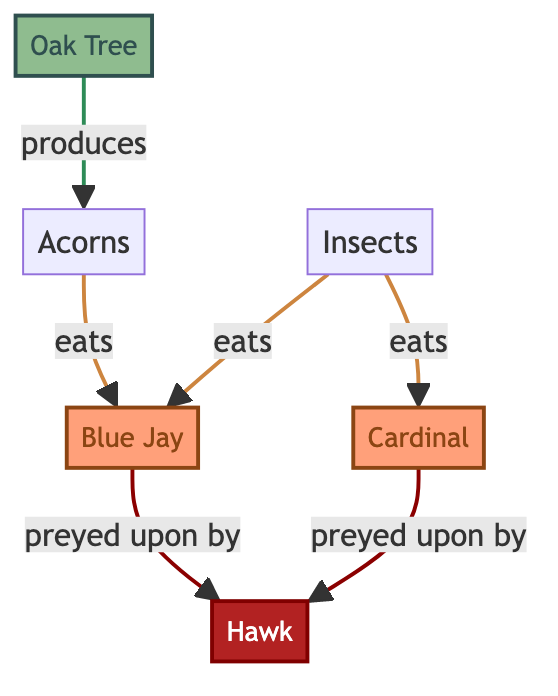What is the primary producer in this food chain? The diagram shows an Oak Tree as the starting point, which is indicated as the primary producer in this food chain.
Answer: Oak Tree How many consumer nodes are in the diagram? There are two consumer nodes, which are the Blue Jay and the Cardinal. By counting these nodes in the diagram, we find a total of two.
Answer: 2 What do Blue Jays eat in this food chain? The diagram indicates that Blue Jays eat both Acorns and Insects. This is clear from the arrows pointing towards the Blue Jay node from these two food sources.
Answer: Acorns and Insects Which bird is at the top of the food chain? The diagram specifies that the Hawk is the predator. It preys on the Blue Jay and Cardinal, placing it at the top of this food chain.
Answer: Hawk What food source do Cardials depend on for nutrition? Looking at the relationships in the diagram, the only food source indicated for Cardinals is Insects, as they are connected through a direct line pointing towards the Cardinal node.
Answer: Insects How many edges connect the producer to consumers? The Oak Tree connects to two distinct edges leading toward the consumers (acorns for Blue Jay and Insects for Blue Jay/Cardinal), thus there are three connections in total.
Answer: 3 Who preys on both Blue Jays and Cardinals? The diagram clearly shows the Hawk as the predator that preys on both the Blue Jay and Cardinal, indicated by the arrows pointing from these two consumer nodes to the Hawk node.
Answer: Hawk How many total nodes are displayed in the diagram? By counting all nodes including producers, consumers, and predators, there are a total of six nodes in the diagram.
Answer: 6 What is the relationship between Acorns and Blue Jays? The diagram establishes a direct relationship where Blue Jays eat Acorns, illustrated by the arrow connecting these two nodes.
Answer: eats 